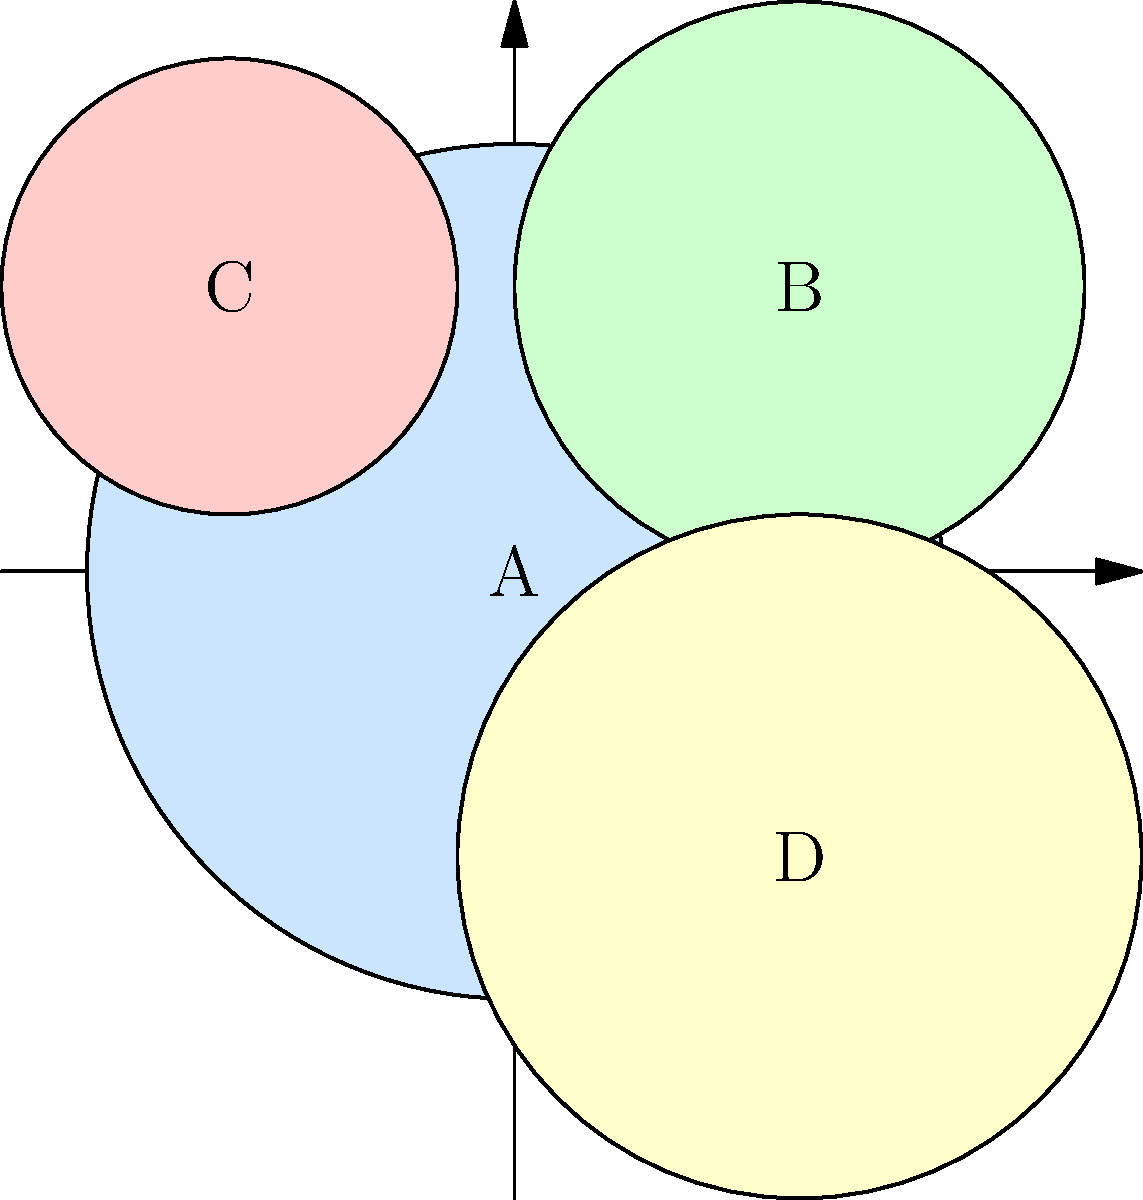As a realtor focused on long-term client relationships, you're analyzing a neighborhood map with color-coded zones representing different property values. Zone A (light blue) has an average property value of $300,000. If Zone B (light green) is known to have property values 20% higher than Zone A, Zone C (light red) is 15% lower than Zone A, and Zone D (light yellow) is 5% higher than Zone A, what is the total estimated value of one property from each zone? To solve this problem, let's break it down step-by-step:

1. Zone A (light blue):
   - Given average property value = $300,000

2. Zone B (light green):
   - 20% higher than Zone A
   - Calculation: $300,000 * (1 + 0.20) = $300,000 * 1.20 = $360,000

3. Zone C (light red):
   - 15% lower than Zone A
   - Calculation: $300,000 * (1 - 0.15) = $300,000 * 0.85 = $255,000

4. Zone D (light yellow):
   - 5% higher than Zone A
   - Calculation: $300,000 * (1 + 0.05) = $300,000 * 1.05 = $315,000

5. Total estimated value of one property from each zone:
   Sum = Zone A + Zone B + Zone C + Zone D
   $300,000 + $360,000 + $255,000 + $315,000 = $1,230,000

This analysis helps in understanding the relative property values across the neighborhood, which is crucial for maintaining good relationships with long-term clients and providing them with accurate market insights.
Answer: $1,230,000 